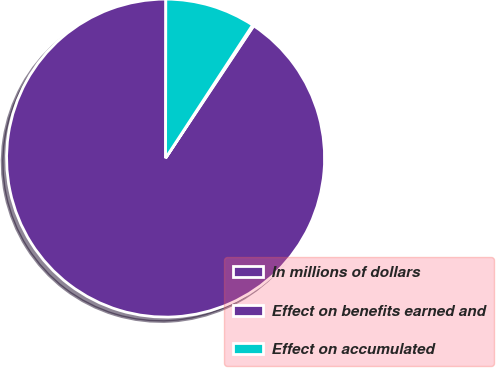Convert chart. <chart><loc_0><loc_0><loc_500><loc_500><pie_chart><fcel>In millions of dollars<fcel>Effect on benefits earned and<fcel>Effect on accumulated<nl><fcel>90.68%<fcel>0.14%<fcel>9.19%<nl></chart> 